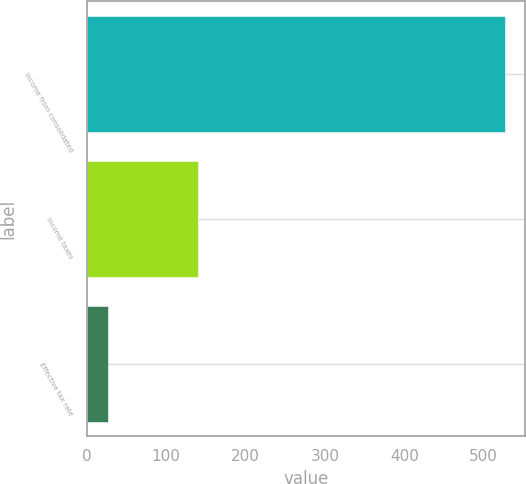Convert chart. <chart><loc_0><loc_0><loc_500><loc_500><bar_chart><fcel>Income from consolidated<fcel>Income taxes<fcel>Effective tax rate<nl><fcel>526.1<fcel>139.8<fcel>26.6<nl></chart> 